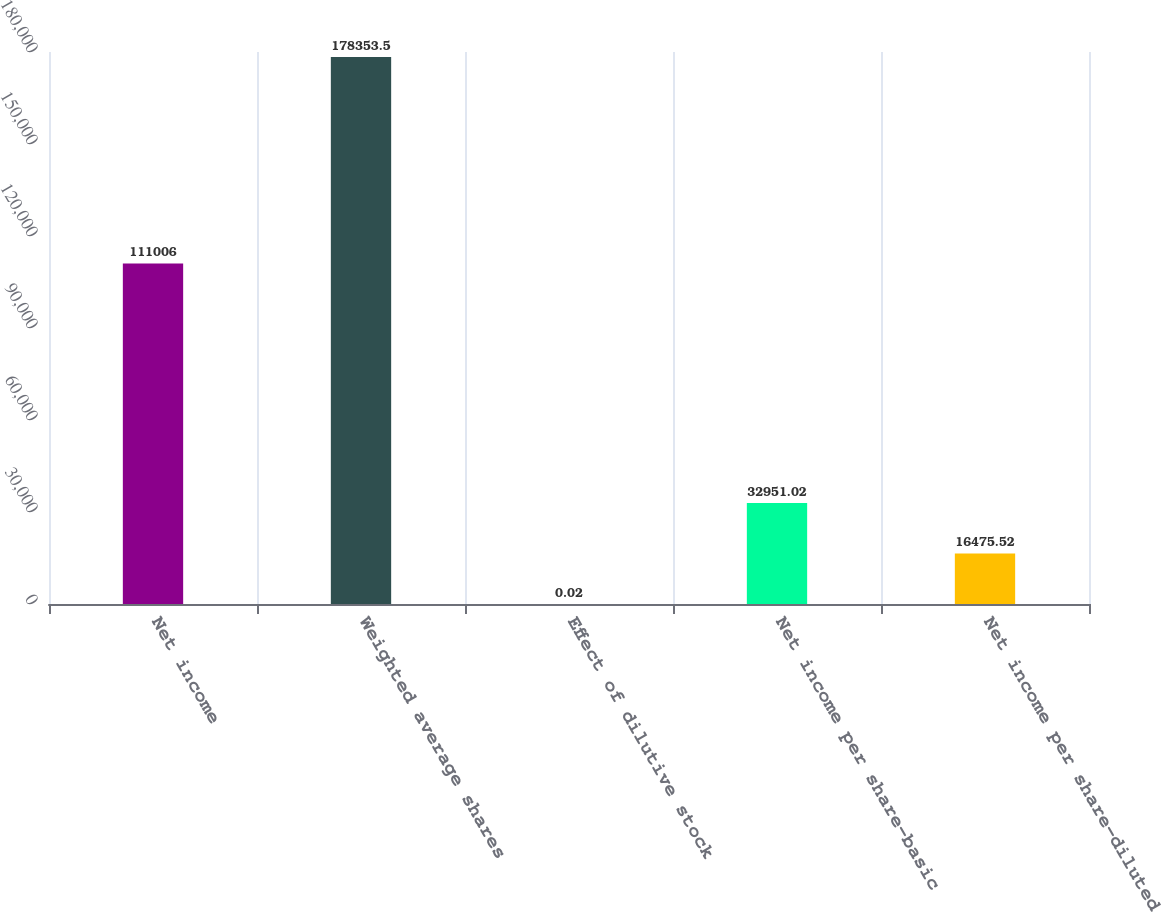Convert chart. <chart><loc_0><loc_0><loc_500><loc_500><bar_chart><fcel>Net income<fcel>Weighted average shares<fcel>Effect of dilutive stock<fcel>Net income per share-basic<fcel>Net income per share-diluted<nl><fcel>111006<fcel>178354<fcel>0.02<fcel>32951<fcel>16475.5<nl></chart> 